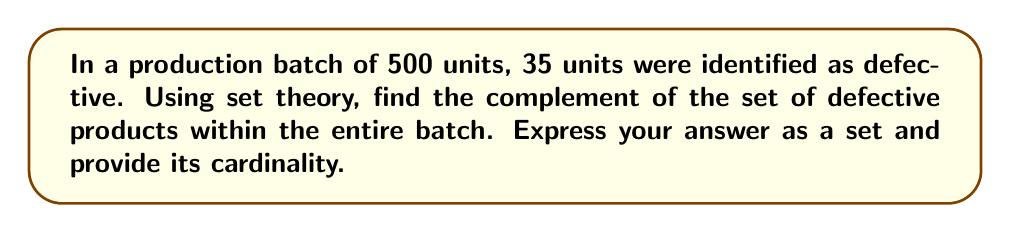Help me with this question. Let's approach this step-by-step:

1) First, let's define our universal set $U$ and the set of defective products $D$:
   
   $U$ = {all products in the batch} = 500 units
   $D$ = {defective products} = 35 units

2) The complement of a set $A$, denoted as $A^c$ or $A'$, is defined as all elements in the universal set that are not in $A$.

3) In this case, we're looking for the complement of $D$, which we can write as $D^c$.

4) $D^c$ will contain all products that are not defective.

5) To find the number of elements in $D^c$, we can subtract the number of defective products from the total number of products:

   $|D^c| = |U| - |D| = 500 - 35 = 465$

6) Therefore, the complement of the defective products set contains 465 units.

7) We can express this set as:
   
   $D^c = \{x \in U : x \text{ is not defective}\}$

8) The cardinality of this set is 465.
Answer: $D^c = \{x \in U : x \text{ is not defective}\}$, $|D^c| = 465$ 